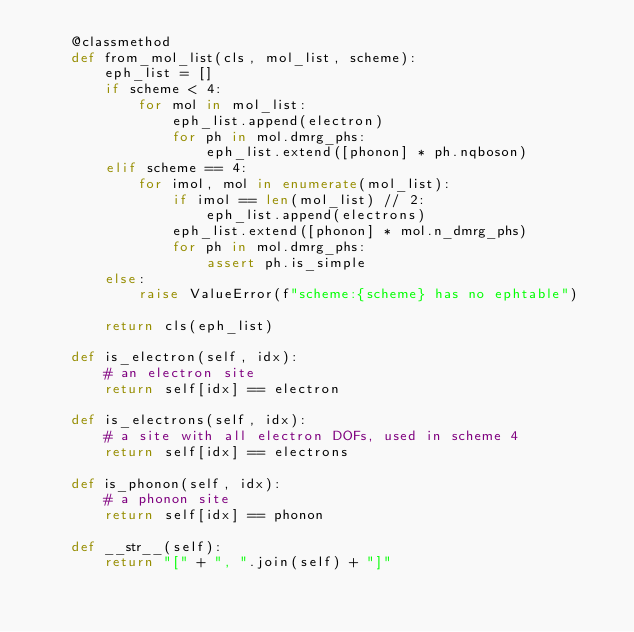Convert code to text. <code><loc_0><loc_0><loc_500><loc_500><_Python_>    @classmethod
    def from_mol_list(cls, mol_list, scheme):
        eph_list = []
        if scheme < 4:
            for mol in mol_list:
                eph_list.append(electron)
                for ph in mol.dmrg_phs:
                    eph_list.extend([phonon] * ph.nqboson)
        elif scheme == 4:
            for imol, mol in enumerate(mol_list):
                if imol == len(mol_list) // 2:
                    eph_list.append(electrons)
                eph_list.extend([phonon] * mol.n_dmrg_phs)
                for ph in mol.dmrg_phs:
                    assert ph.is_simple
        else:
            raise ValueError(f"scheme:{scheme} has no ephtable")

        return cls(eph_list)

    def is_electron(self, idx):
        # an electron site
        return self[idx] == electron

    def is_electrons(self, idx):
        # a site with all electron DOFs, used in scheme 4
        return self[idx] == electrons

    def is_phonon(self, idx):
        # a phonon site
        return self[idx] == phonon

    def __str__(self):
        return "[" + ", ".join(self) + "]"
</code> 